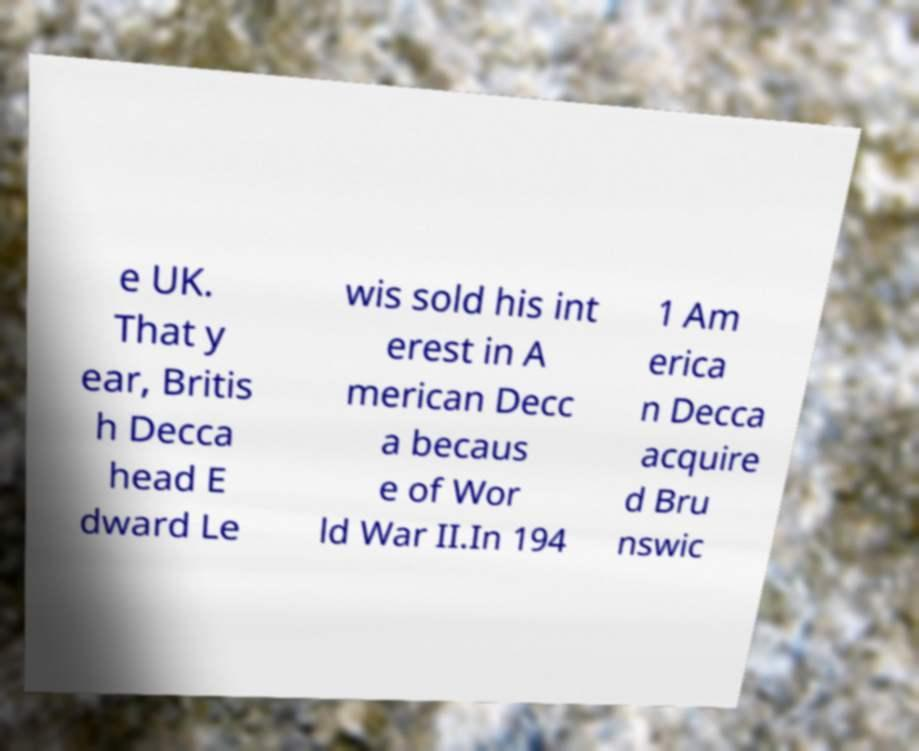I need the written content from this picture converted into text. Can you do that? e UK. That y ear, Britis h Decca head E dward Le wis sold his int erest in A merican Decc a becaus e of Wor ld War II.In 194 1 Am erica n Decca acquire d Bru nswic 